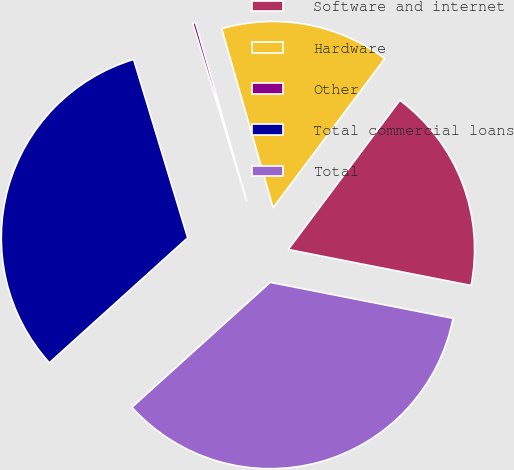Convert chart. <chart><loc_0><loc_0><loc_500><loc_500><pie_chart><fcel>Software and internet<fcel>Hardware<fcel>Other<fcel>Total commercial loans<fcel>Total<nl><fcel>17.87%<fcel>14.67%<fcel>0.24%<fcel>32.01%<fcel>35.21%<nl></chart> 